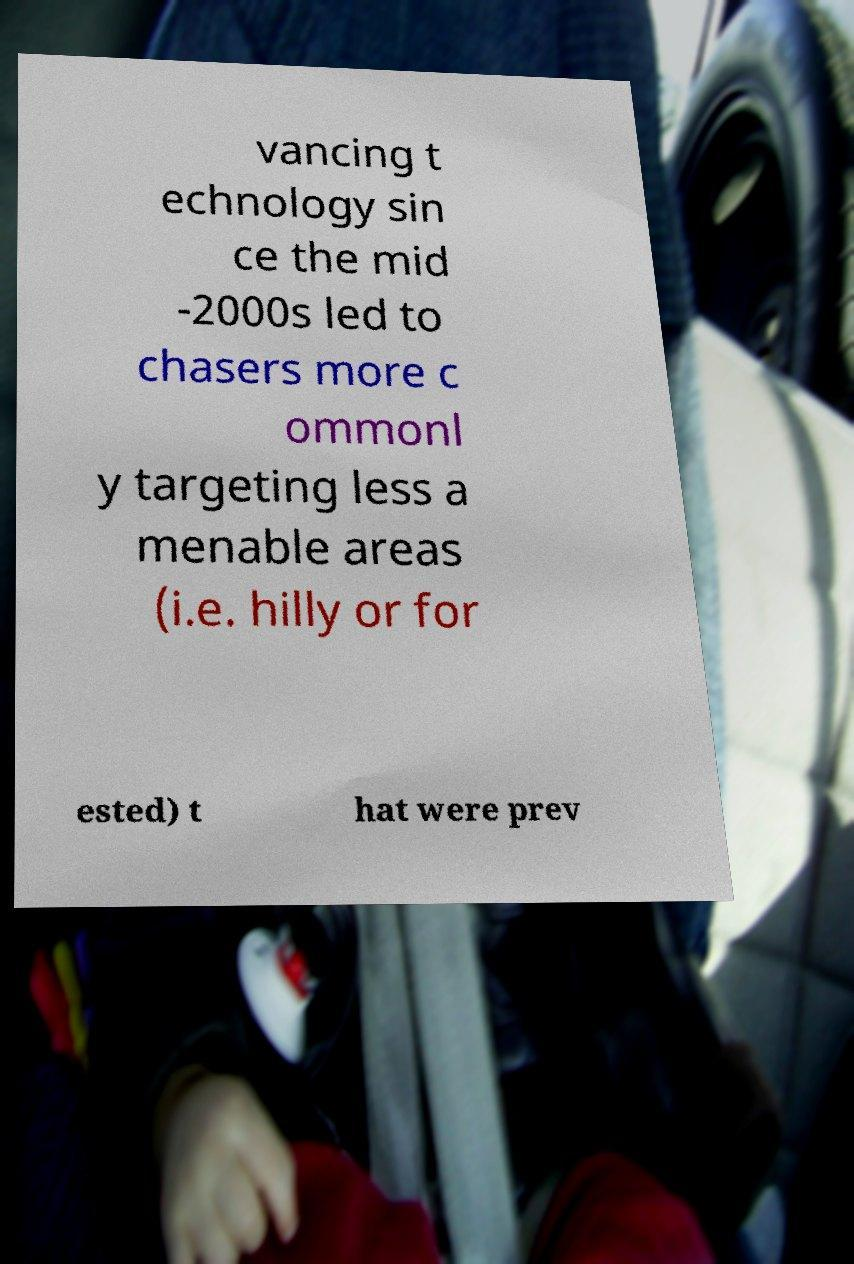Please read and relay the text visible in this image. What does it say? vancing t echnology sin ce the mid -2000s led to chasers more c ommonl y targeting less a menable areas (i.e. hilly or for ested) t hat were prev 